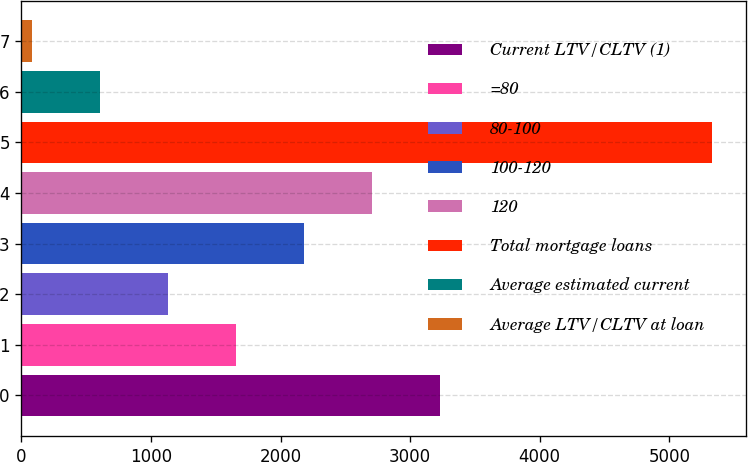Convert chart to OTSL. <chart><loc_0><loc_0><loc_500><loc_500><bar_chart><fcel>Current LTV/CLTV (1)<fcel>=80<fcel>80-100<fcel>100-120<fcel>120<fcel>Total mortgage loans<fcel>Average estimated current<fcel>Average LTV/CLTV at loan<nl><fcel>3228.9<fcel>1654.05<fcel>1129.1<fcel>2179<fcel>2703.95<fcel>5328.7<fcel>604.15<fcel>79.2<nl></chart> 